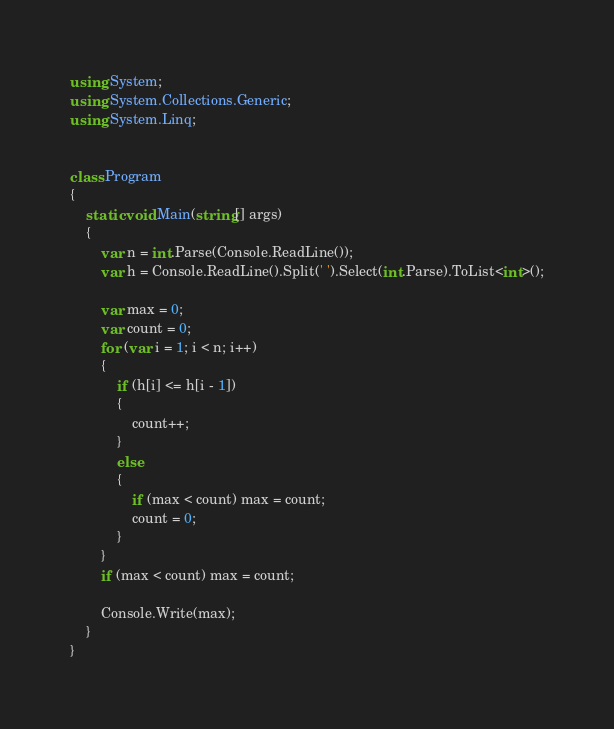<code> <loc_0><loc_0><loc_500><loc_500><_C#_>using System;
using System.Collections.Generic;
using System.Linq;


class Program
{
    static void Main(string[] args)
    {
        var n = int.Parse(Console.ReadLine());
        var h = Console.ReadLine().Split(' ').Select(int.Parse).ToList<int>();

        var max = 0;
        var count = 0;
        for (var i = 1; i < n; i++)
        {
            if (h[i] <= h[i - 1])
            {
                count++;
            }
            else
            {
                if (max < count) max = count;
                count = 0;
            }
        }
        if (max < count) max = count;

        Console.Write(max);
    }
}
</code> 